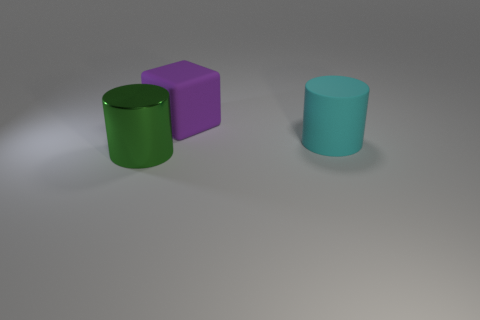What is the size of the cyan object that is made of the same material as the purple object?
Offer a terse response. Large. Is the material of the large purple thing the same as the green object?
Your answer should be very brief. No. How many other things are the same shape as the purple matte thing?
Provide a succinct answer. 0. How many objects are cylinders or tiny yellow rubber cylinders?
Offer a very short reply. 2. How many other things are there of the same size as the purple block?
Provide a short and direct response. 2. Is the color of the big metallic object the same as the object that is behind the big cyan matte object?
Ensure brevity in your answer.  No. How many spheres are big green objects or purple shiny objects?
Give a very brief answer. 0. What is the material of the big object that is behind the cylinder that is behind the green cylinder?
Provide a short and direct response. Rubber. Are the big cyan object and the large cylinder that is on the left side of the rubber block made of the same material?
Your answer should be compact. No. What number of objects are purple rubber blocks right of the green metallic thing or big objects?
Keep it short and to the point. 3. 